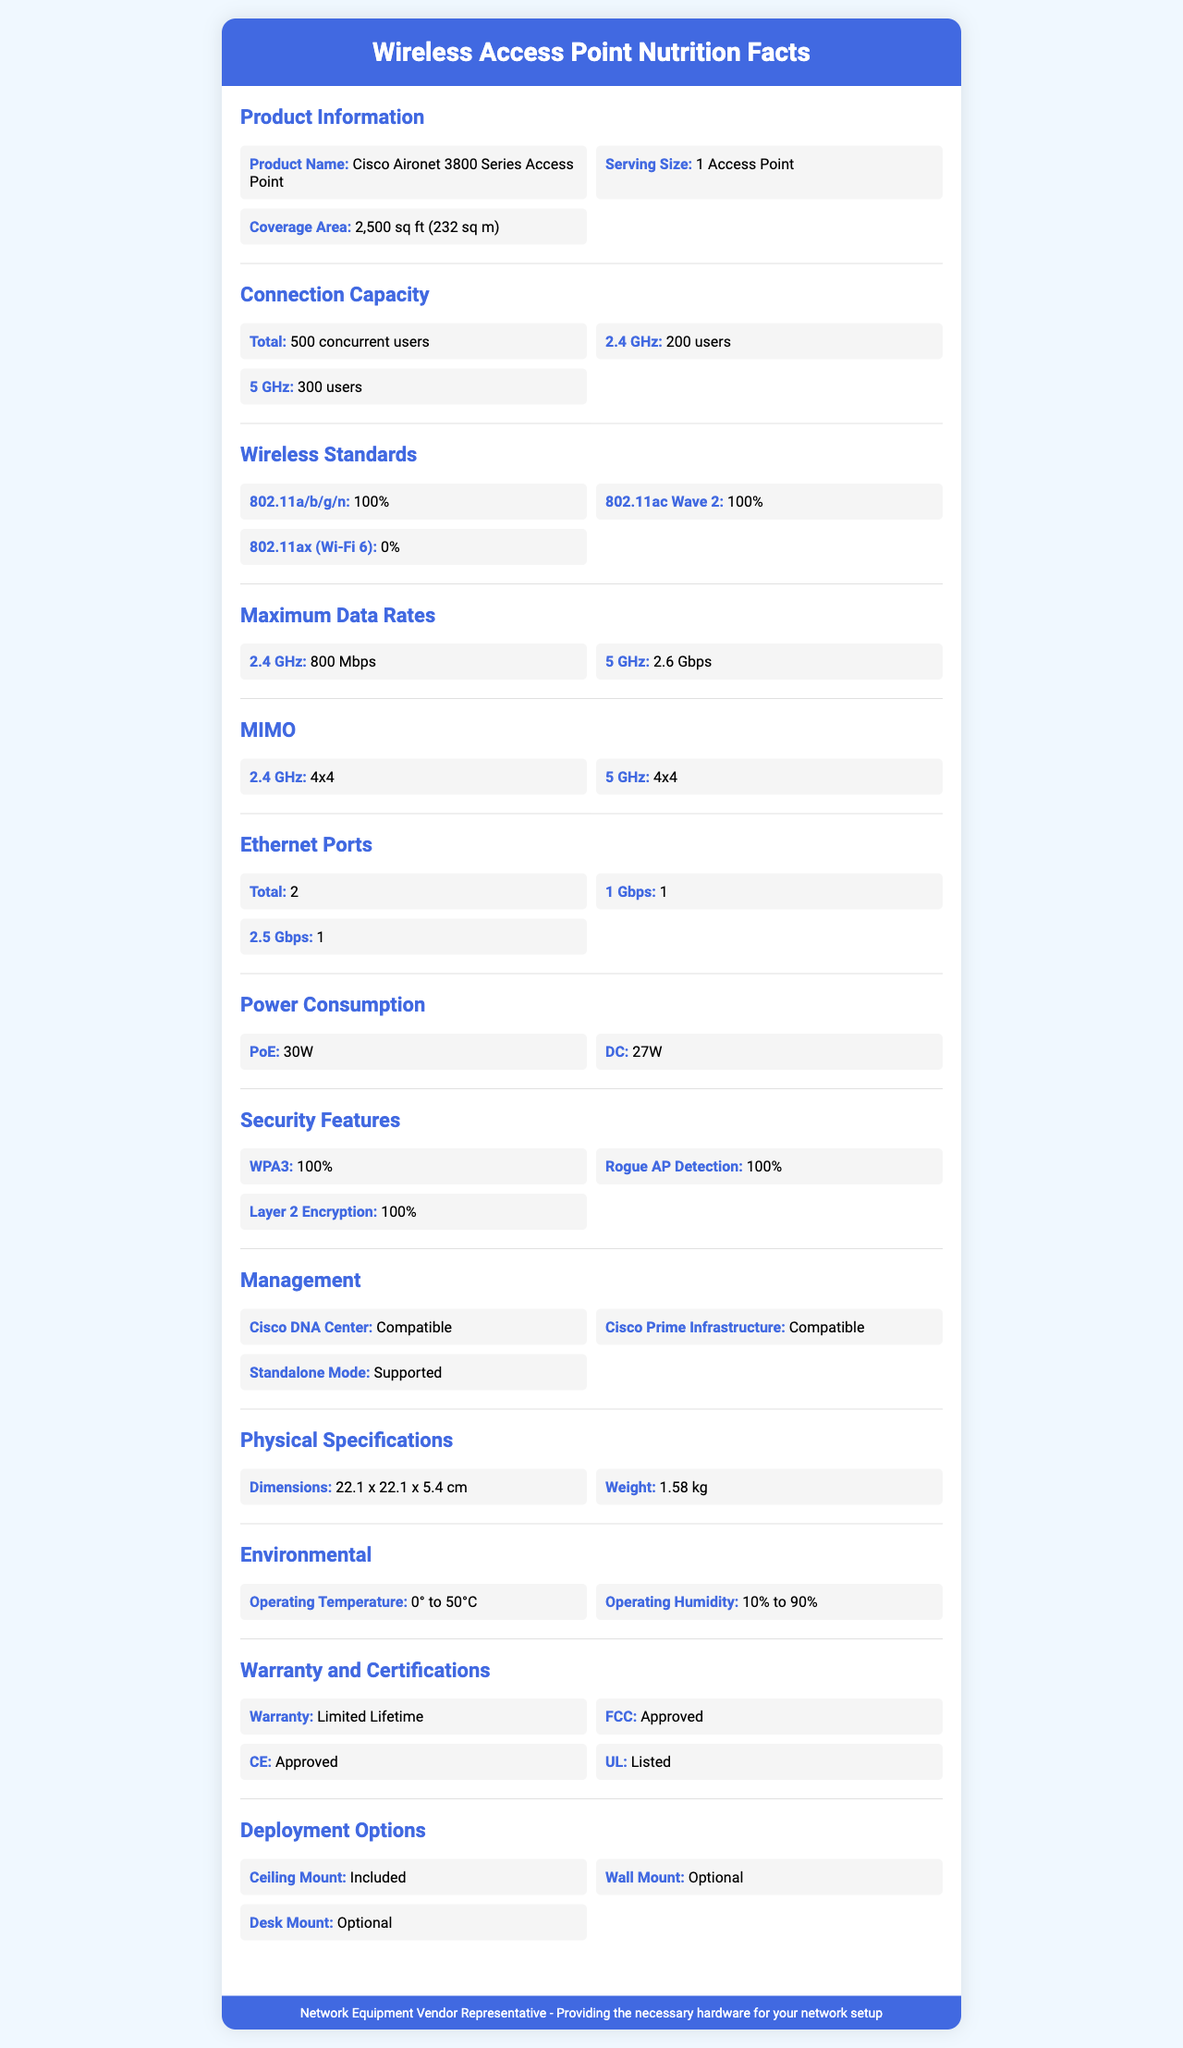what is the coverage area of the Cisco Aironet 3800 Series Access Point? The coverage area is clearly stated under the 'Coverage Area' section of the document.
Answer: 2,500 sq ft (232 sq m) what is the maximum data rate for the 5 GHz band? The maximum data rate for the 5 GHz band is listed in the 'Maximum Data Rates' section.
Answer: 2.6 Gbps how many concurrent users can the 2.4 GHz band support? The connection capacity for the 2.4 GHz band is shown under the 'Connection Capacity' section.
Answer: 200 users are the dimensions of the access point included in the document? The dimensions are listed under the 'Physical Specifications' section as 22.1 x 22.1 x 5.4 cm.
Answer: Yes does the Cisco Aironet 3800 Series Access Point support Wi-Fi 6 (802.11ax)? The document states that the support for 802.11ax (Wi-Fi 6) is 0%, indicating it is not supported.
Answer: No how many Ethernet ports does the access point have? The number of Ethernet ports is specified in the 'Ethernet Ports' section.
Answer: 2 what is the power consumption when using PoE? The power consumption under the 'PoE' section of 'Power Consumption' is 30W.
Answer: 30W which of the following security features does the access point support? A. WPA3 B. WPA2 C. MAC Address Filtering The document mentions that WPA3 is supported, but there's no information about WPA2 or MAC Address Filtering.
Answer: A. WPA3 what is the weight of the access point? The weight is provided in the 'Physical Specifications' section as 1.58 kg.
Answer: 1.58 kg what is the operation temperature range for the access point? The operating temperature is listed under the 'Environmental' section as 0° to 50°C.
Answer: 0° to 50°C does the Cisco Aironet 3800 Series Access Point support ceiling mount installation? The 'Deployment Options' section states that ceiling mount is included.
Answer: Yes which management tools are compatible with the access point? A. Cisco DNA Center B. Cisco Prime Infrastructure C. Standalone Mode D. All of the above The document lists all three management tools as compatible in the 'Management' section.
Answer: D. All of the above is the access point FCC approved? The 'Certifications' section confirms that the access point is FCC approved.
Answer: Yes provide a brief summary of the Cisco Aironet 3800 Series Access Point document. The summary synthesizes all principal information provided in the document regarding specifications, capacity, standards, physical properties, and certifications.
Answer: The Cisco Aironet 3800 Series Access Point offers robust wireless coverage over 2,500 sq ft and can support up to 500 concurrent users. It includes 2.4 GHz and 5 GHz bands, with maximum data rates of 800 Mbps and 2.6 Gbps, respectively. The unit supports wireless standards 802.11a/b/g/n and 802.11ac Wave 2, but not 802.11ax. It features various security measures and is compatible with multiple management tools. The physical specifications include dimensions of 22.1 x 22.1 x 5.4 cm and a weight of 1.58 kg. It can operate within a temperature range of 0° to 50°C, supports ceiling mount deployment, and has multiple certifications. how does the access point provide backup power in case of a failure? The document does not provide any details about backup power features or capabilities for the access point.
Answer: Not enough information 